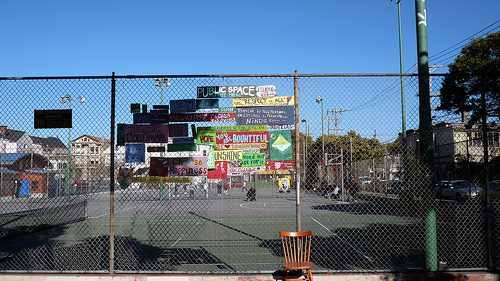<image>
Is the sign above the chair? Yes. The sign is positioned above the chair in the vertical space, higher up in the scene. Is the fence behind the chair? Yes. From this viewpoint, the fence is positioned behind the chair, with the chair partially or fully occluding the fence. 